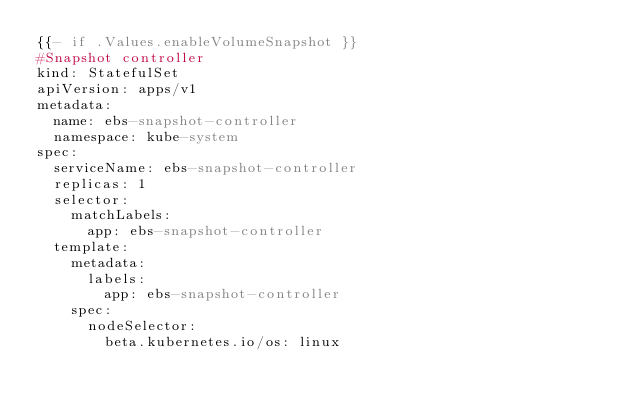Convert code to text. <code><loc_0><loc_0><loc_500><loc_500><_YAML_>{{- if .Values.enableVolumeSnapshot }}
#Snapshot controller
kind: StatefulSet
apiVersion: apps/v1
metadata:
  name: ebs-snapshot-controller
  namespace: kube-system
spec:
  serviceName: ebs-snapshot-controller
  replicas: 1
  selector:
    matchLabels:
      app: ebs-snapshot-controller
  template:
    metadata:
      labels:
        app: ebs-snapshot-controller
    spec:
      nodeSelector:
        beta.kubernetes.io/os: linux</code> 